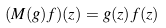<formula> <loc_0><loc_0><loc_500><loc_500>( M ( g ) f ) ( z ) = g ( z ) f ( z )</formula> 